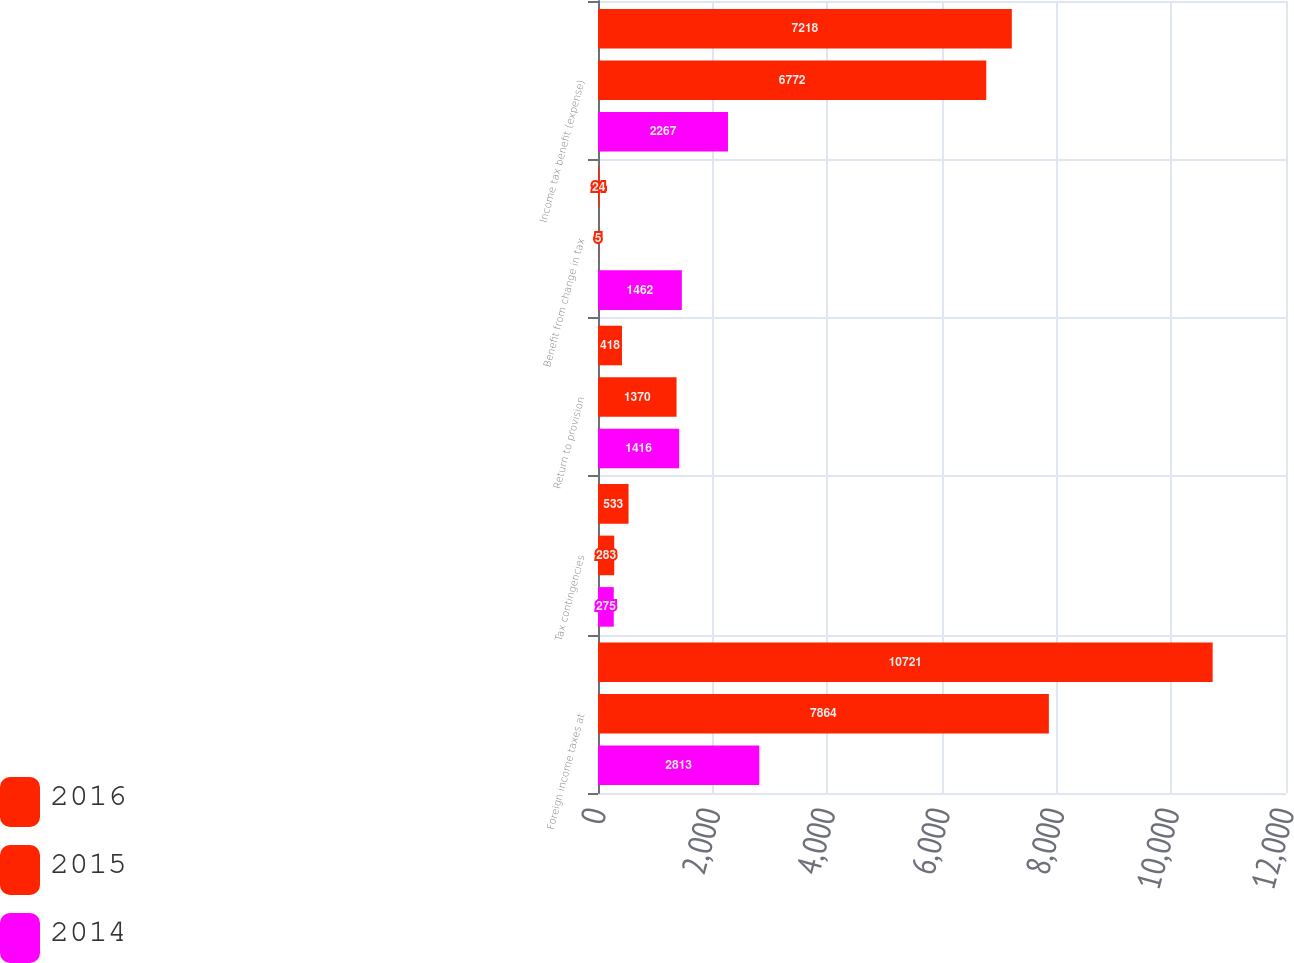Convert chart to OTSL. <chart><loc_0><loc_0><loc_500><loc_500><stacked_bar_chart><ecel><fcel>Foreign income taxes at<fcel>Tax contingencies<fcel>Return to provision<fcel>Benefit from change in tax<fcel>Income tax benefit (expense)<nl><fcel>2016<fcel>10721<fcel>533<fcel>418<fcel>24<fcel>7218<nl><fcel>2015<fcel>7864<fcel>283<fcel>1370<fcel>5<fcel>6772<nl><fcel>2014<fcel>2813<fcel>275<fcel>1416<fcel>1462<fcel>2267<nl></chart> 